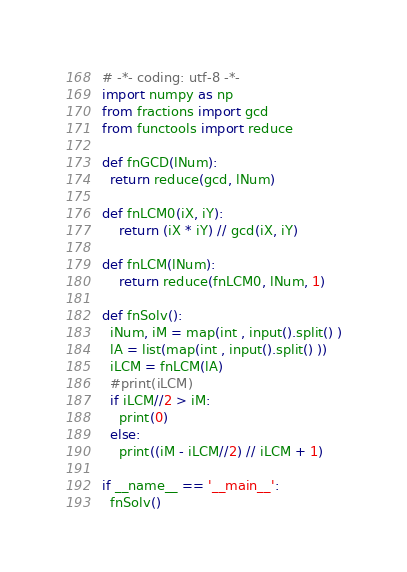Convert code to text. <code><loc_0><loc_0><loc_500><loc_500><_Python_># -*- coding: utf-8 -*-
import numpy as np
from fractions import gcd
from functools import reduce

def fnGCD(lNum):
  return reduce(gcd, lNum)

def fnLCM0(iX, iY):
    return (iX * iY) // gcd(iX, iY)

def fnLCM(lNum):
    return reduce(fnLCM0, lNum, 1)

def fnSolv():
  iNum, iM = map(int , input().split() )
  lA = list(map(int , input().split() ))
  iLCM = fnLCM(lA)
  #print(iLCM)
  if iLCM//2 > iM:
    print(0)
  else:
    print((iM - iLCM//2) // iLCM + 1)

if __name__ == '__main__':
  fnSolv()
</code> 